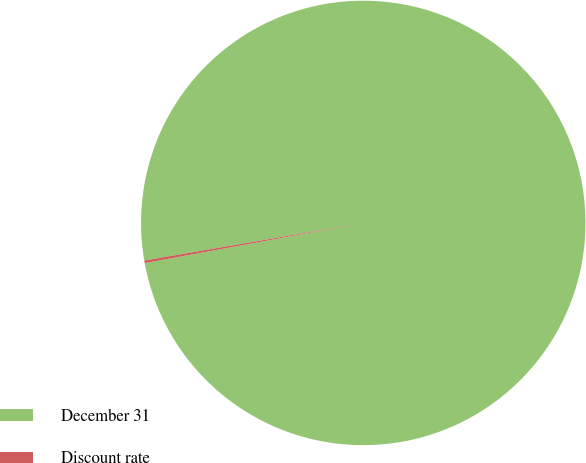Convert chart to OTSL. <chart><loc_0><loc_0><loc_500><loc_500><pie_chart><fcel>December 31<fcel>Discount rate<nl><fcel>99.81%<fcel>0.19%<nl></chart> 